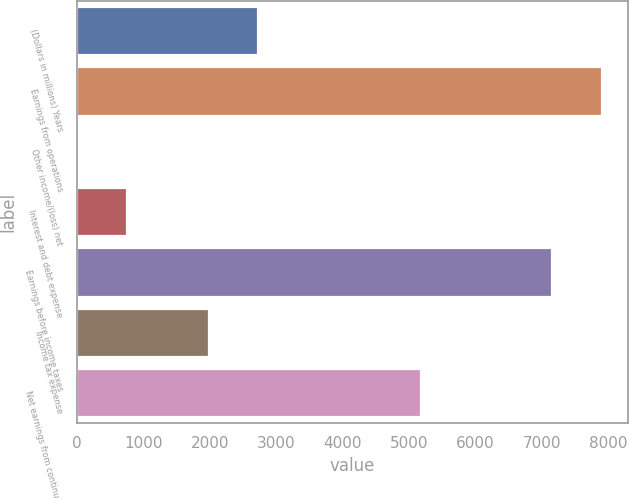Convert chart to OTSL. <chart><loc_0><loc_0><loc_500><loc_500><bar_chart><fcel>(Dollars in millions) Years<fcel>Earnings from operations<fcel>Other income/(loss) net<fcel>Interest and debt expense<fcel>Earnings before income taxes<fcel>Income tax expense<fcel>Net earnings from continuing<nl><fcel>2722<fcel>7898<fcel>13<fcel>756<fcel>7155<fcel>1979<fcel>5176<nl></chart> 